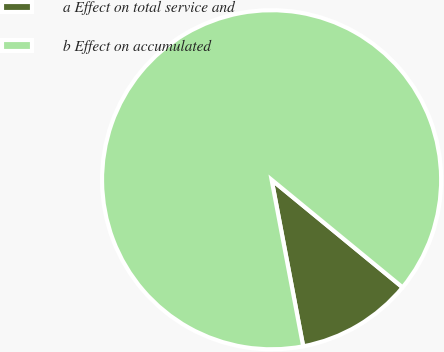<chart> <loc_0><loc_0><loc_500><loc_500><pie_chart><fcel>a Effect on total service and<fcel>b Effect on accumulated<nl><fcel>11.07%<fcel>88.93%<nl></chart> 